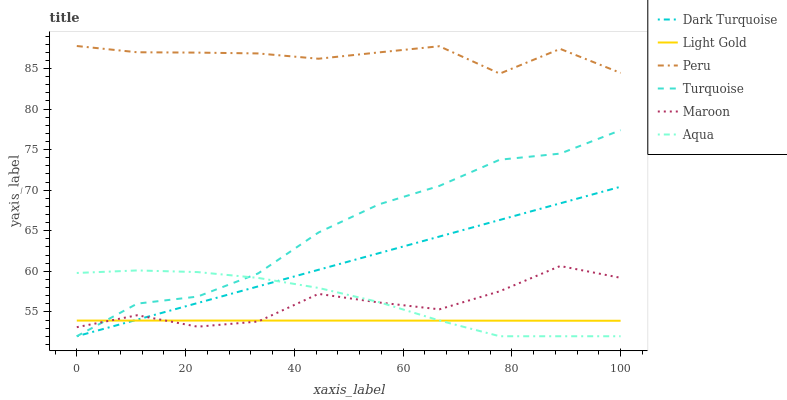Does Light Gold have the minimum area under the curve?
Answer yes or no. Yes. Does Peru have the maximum area under the curve?
Answer yes or no. Yes. Does Dark Turquoise have the minimum area under the curve?
Answer yes or no. No. Does Dark Turquoise have the maximum area under the curve?
Answer yes or no. No. Is Dark Turquoise the smoothest?
Answer yes or no. Yes. Is Maroon the roughest?
Answer yes or no. Yes. Is Aqua the smoothest?
Answer yes or no. No. Is Aqua the roughest?
Answer yes or no. No. Does Turquoise have the lowest value?
Answer yes or no. Yes. Does Maroon have the lowest value?
Answer yes or no. No. Does Peru have the highest value?
Answer yes or no. Yes. Does Dark Turquoise have the highest value?
Answer yes or no. No. Is Aqua less than Peru?
Answer yes or no. Yes. Is Peru greater than Dark Turquoise?
Answer yes or no. Yes. Does Aqua intersect Turquoise?
Answer yes or no. Yes. Is Aqua less than Turquoise?
Answer yes or no. No. Is Aqua greater than Turquoise?
Answer yes or no. No. Does Aqua intersect Peru?
Answer yes or no. No. 